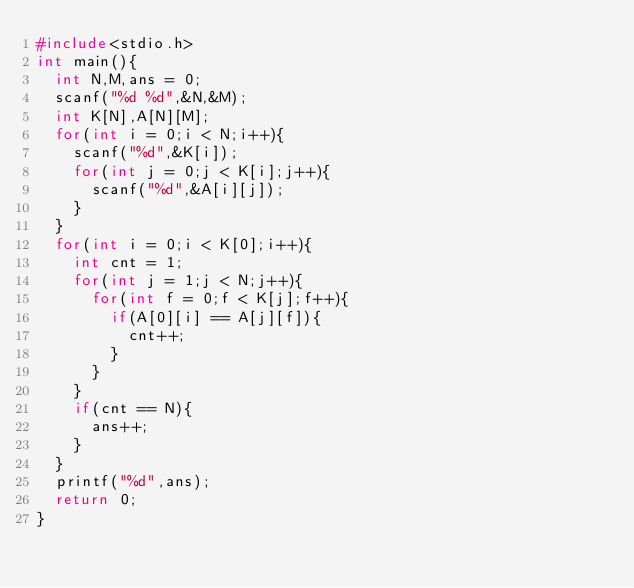Convert code to text. <code><loc_0><loc_0><loc_500><loc_500><_C_>#include<stdio.h>
int main(){
  int N,M,ans = 0;
  scanf("%d %d",&N,&M);
  int K[N],A[N][M];
  for(int i = 0;i < N;i++){
    scanf("%d",&K[i]);
    for(int j = 0;j < K[i];j++){
      scanf("%d",&A[i][j]);
    }
  }
  for(int i = 0;i < K[0];i++){
    int cnt = 1;
    for(int j = 1;j < N;j++){
      for(int f = 0;f < K[j];f++){
        if(A[0][i] == A[j][f]){
          cnt++;
        }
      }
    }
    if(cnt == N){
      ans++;
    }
  }
  printf("%d",ans);
  return 0;
}</code> 